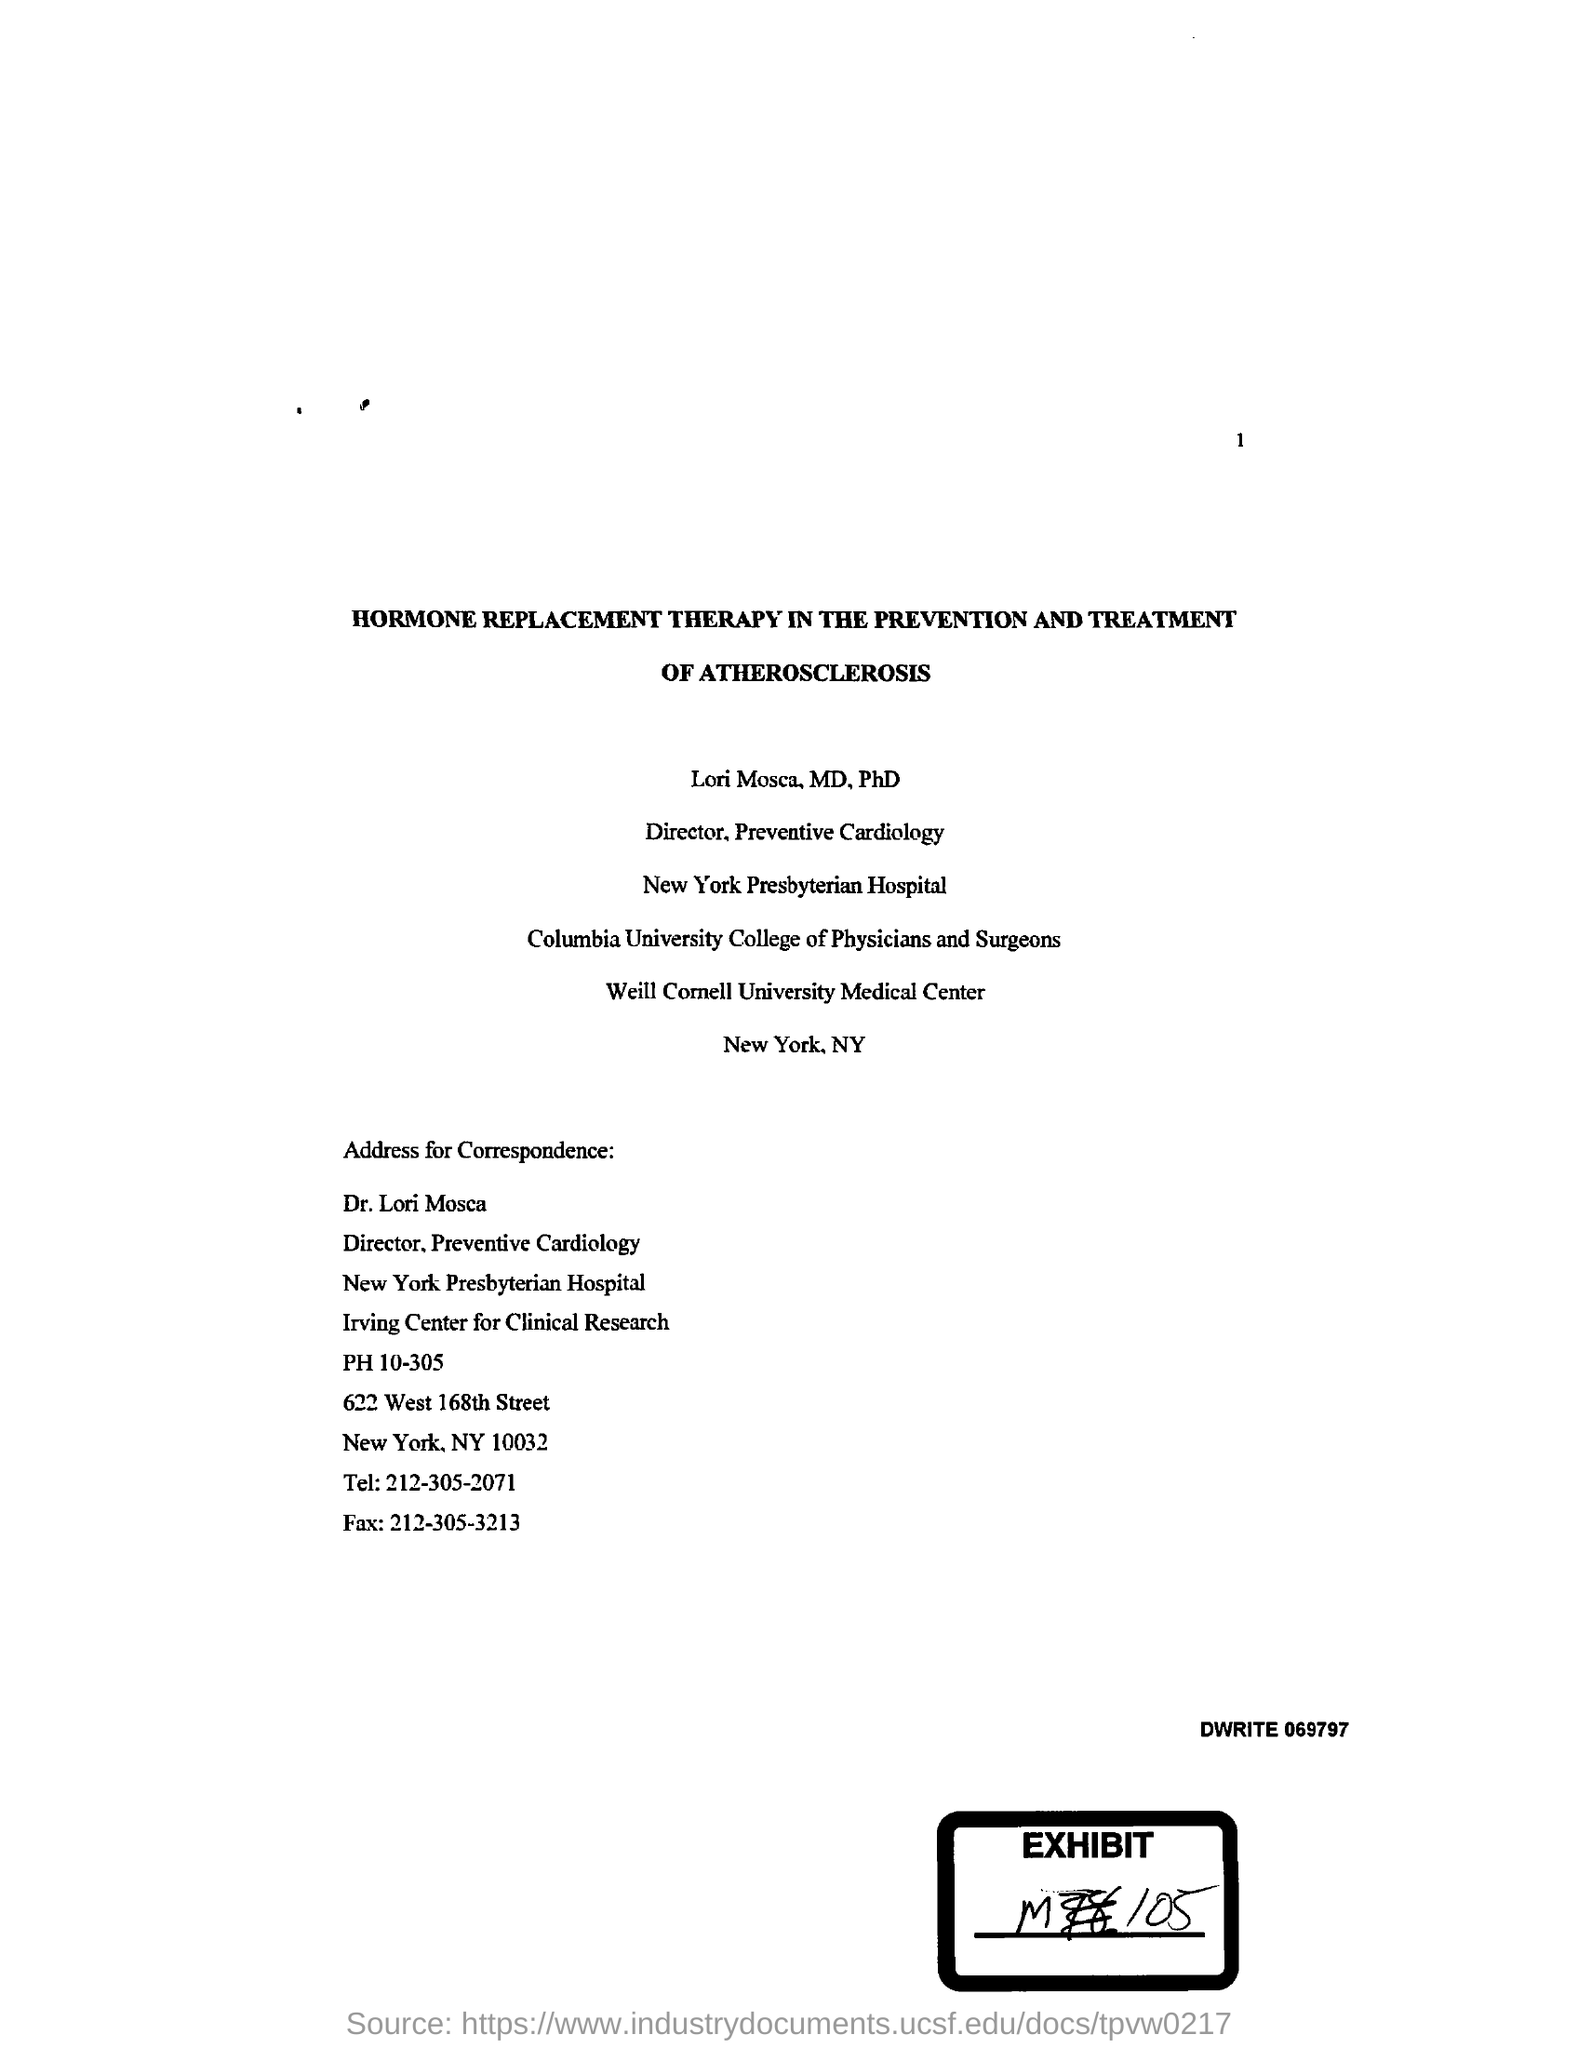Mention a couple of crucial points in this snapshot. The telephone number given in the letter is 212-305-2071. The name of the therapy mentioned in the given page is hormone replacement therapy. Dr. Lori Mosca works at New York Presbyterian Hospital. The fax number mentioned in the given page is 212-305-3213. 